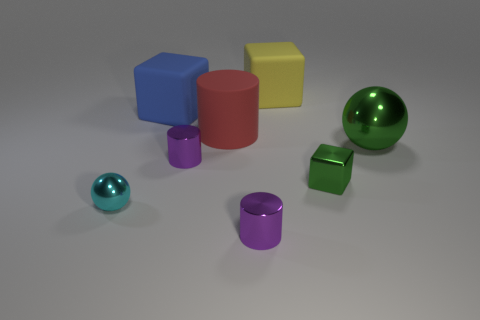Subtract all yellow rubber cubes. How many cubes are left? 2 Subtract all green blocks. How many purple cylinders are left? 2 Add 2 gray shiny blocks. How many objects exist? 10 Subtract all purple cylinders. How many cylinders are left? 1 Subtract all cylinders. How many objects are left? 5 Subtract 0 cyan cylinders. How many objects are left? 8 Subtract 1 spheres. How many spheres are left? 1 Subtract all brown blocks. Subtract all brown cylinders. How many blocks are left? 3 Subtract all large yellow blocks. Subtract all large spheres. How many objects are left? 6 Add 1 spheres. How many spheres are left? 3 